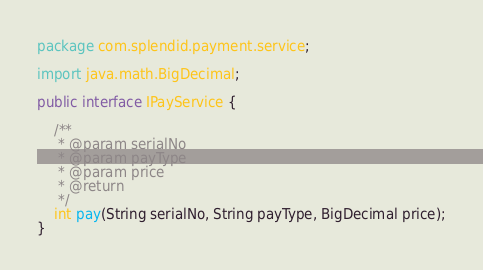Convert code to text. <code><loc_0><loc_0><loc_500><loc_500><_Java_>package com.splendid.payment.service;

import java.math.BigDecimal;

public interface IPayService {

	/**
	 * @param serialNo
	 * @param payType
	 * @param price
	 * @return
	 */
	int pay(String serialNo, String payType, BigDecimal price);
}
</code> 